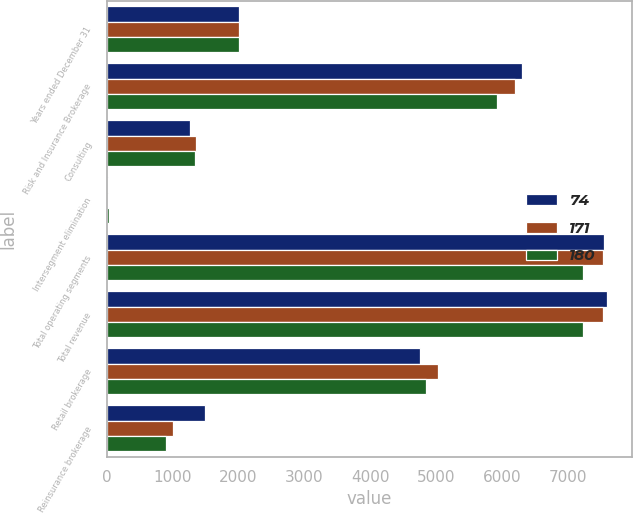Convert chart. <chart><loc_0><loc_0><loc_500><loc_500><stacked_bar_chart><ecel><fcel>Years ended December 31<fcel>Risk and Insurance Brokerage<fcel>Consulting<fcel>Intersegment elimination<fcel>Total operating segments<fcel>Total revenue<fcel>Retail brokerage<fcel>Reinsurance brokerage<nl><fcel>74<fcel>2009<fcel>6305<fcel>1267<fcel>26<fcel>7546<fcel>7595<fcel>4747<fcel>1485<nl><fcel>171<fcel>2008<fcel>6197<fcel>1356<fcel>25<fcel>7528<fcel>7528<fcel>5028<fcel>1001<nl><fcel>180<fcel>2007<fcel>5918<fcel>1345<fcel>29<fcel>7234<fcel>7234<fcel>4841<fcel>900<nl></chart> 